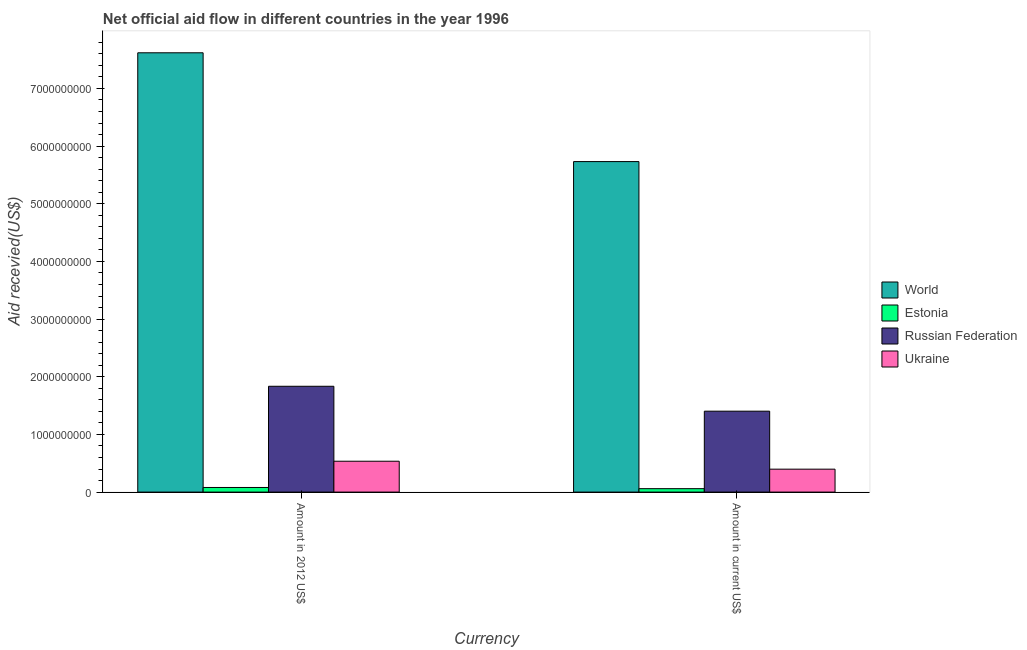How many groups of bars are there?
Provide a succinct answer. 2. Are the number of bars per tick equal to the number of legend labels?
Provide a short and direct response. Yes. Are the number of bars on each tick of the X-axis equal?
Offer a terse response. Yes. What is the label of the 1st group of bars from the left?
Your response must be concise. Amount in 2012 US$. What is the amount of aid received(expressed in 2012 us$) in Russian Federation?
Give a very brief answer. 1.84e+09. Across all countries, what is the maximum amount of aid received(expressed in us$)?
Your answer should be very brief. 5.73e+09. Across all countries, what is the minimum amount of aid received(expressed in 2012 us$)?
Ensure brevity in your answer.  7.99e+07. In which country was the amount of aid received(expressed in 2012 us$) minimum?
Give a very brief answer. Estonia. What is the total amount of aid received(expressed in us$) in the graph?
Provide a short and direct response. 7.59e+09. What is the difference between the amount of aid received(expressed in us$) in Estonia and that in Russian Federation?
Offer a terse response. -1.34e+09. What is the difference between the amount of aid received(expressed in us$) in Ukraine and the amount of aid received(expressed in 2012 us$) in Russian Federation?
Keep it short and to the point. -1.44e+09. What is the average amount of aid received(expressed in 2012 us$) per country?
Provide a succinct answer. 2.52e+09. What is the difference between the amount of aid received(expressed in us$) and amount of aid received(expressed in 2012 us$) in Russian Federation?
Give a very brief answer. -4.32e+08. In how many countries, is the amount of aid received(expressed in us$) greater than 1000000000 US$?
Offer a terse response. 2. What is the ratio of the amount of aid received(expressed in us$) in Ukraine to that in Russian Federation?
Provide a short and direct response. 0.28. Is the amount of aid received(expressed in us$) in Estonia less than that in Russian Federation?
Give a very brief answer. Yes. What does the 3rd bar from the left in Amount in current US$ represents?
Provide a succinct answer. Russian Federation. What does the 2nd bar from the right in Amount in 2012 US$ represents?
Provide a short and direct response. Russian Federation. How many countries are there in the graph?
Offer a terse response. 4. What is the difference between two consecutive major ticks on the Y-axis?
Offer a terse response. 1.00e+09. Does the graph contain grids?
Your answer should be very brief. No. Where does the legend appear in the graph?
Offer a terse response. Center right. How many legend labels are there?
Ensure brevity in your answer.  4. What is the title of the graph?
Keep it short and to the point. Net official aid flow in different countries in the year 1996. What is the label or title of the X-axis?
Offer a terse response. Currency. What is the label or title of the Y-axis?
Provide a succinct answer. Aid recevied(US$). What is the Aid recevied(US$) in World in Amount in 2012 US$?
Offer a very short reply. 7.62e+09. What is the Aid recevied(US$) of Estonia in Amount in 2012 US$?
Offer a very short reply. 7.99e+07. What is the Aid recevied(US$) of Russian Federation in Amount in 2012 US$?
Ensure brevity in your answer.  1.84e+09. What is the Aid recevied(US$) in Ukraine in Amount in 2012 US$?
Give a very brief answer. 5.35e+08. What is the Aid recevied(US$) in World in Amount in current US$?
Offer a very short reply. 5.73e+09. What is the Aid recevied(US$) of Estonia in Amount in current US$?
Give a very brief answer. 5.94e+07. What is the Aid recevied(US$) in Russian Federation in Amount in current US$?
Offer a terse response. 1.40e+09. What is the Aid recevied(US$) in Ukraine in Amount in current US$?
Your answer should be compact. 3.98e+08. Across all Currency, what is the maximum Aid recevied(US$) in World?
Make the answer very short. 7.62e+09. Across all Currency, what is the maximum Aid recevied(US$) of Estonia?
Your answer should be very brief. 7.99e+07. Across all Currency, what is the maximum Aid recevied(US$) of Russian Federation?
Ensure brevity in your answer.  1.84e+09. Across all Currency, what is the maximum Aid recevied(US$) in Ukraine?
Offer a terse response. 5.35e+08. Across all Currency, what is the minimum Aid recevied(US$) in World?
Ensure brevity in your answer.  5.73e+09. Across all Currency, what is the minimum Aid recevied(US$) of Estonia?
Offer a very short reply. 5.94e+07. Across all Currency, what is the minimum Aid recevied(US$) in Russian Federation?
Ensure brevity in your answer.  1.40e+09. Across all Currency, what is the minimum Aid recevied(US$) in Ukraine?
Keep it short and to the point. 3.98e+08. What is the total Aid recevied(US$) of World in the graph?
Your response must be concise. 1.34e+1. What is the total Aid recevied(US$) in Estonia in the graph?
Your answer should be very brief. 1.39e+08. What is the total Aid recevied(US$) of Russian Federation in the graph?
Provide a succinct answer. 3.24e+09. What is the total Aid recevied(US$) in Ukraine in the graph?
Your answer should be compact. 9.33e+08. What is the difference between the Aid recevied(US$) of World in Amount in 2012 US$ and that in Amount in current US$?
Give a very brief answer. 1.89e+09. What is the difference between the Aid recevied(US$) of Estonia in Amount in 2012 US$ and that in Amount in current US$?
Make the answer very short. 2.05e+07. What is the difference between the Aid recevied(US$) of Russian Federation in Amount in 2012 US$ and that in Amount in current US$?
Give a very brief answer. 4.32e+08. What is the difference between the Aid recevied(US$) in Ukraine in Amount in 2012 US$ and that in Amount in current US$?
Your response must be concise. 1.37e+08. What is the difference between the Aid recevied(US$) of World in Amount in 2012 US$ and the Aid recevied(US$) of Estonia in Amount in current US$?
Provide a short and direct response. 7.56e+09. What is the difference between the Aid recevied(US$) in World in Amount in 2012 US$ and the Aid recevied(US$) in Russian Federation in Amount in current US$?
Your response must be concise. 6.22e+09. What is the difference between the Aid recevied(US$) of World in Amount in 2012 US$ and the Aid recevied(US$) of Ukraine in Amount in current US$?
Your answer should be compact. 7.22e+09. What is the difference between the Aid recevied(US$) in Estonia in Amount in 2012 US$ and the Aid recevied(US$) in Russian Federation in Amount in current US$?
Provide a succinct answer. -1.32e+09. What is the difference between the Aid recevied(US$) in Estonia in Amount in 2012 US$ and the Aid recevied(US$) in Ukraine in Amount in current US$?
Your answer should be compact. -3.18e+08. What is the difference between the Aid recevied(US$) of Russian Federation in Amount in 2012 US$ and the Aid recevied(US$) of Ukraine in Amount in current US$?
Give a very brief answer. 1.44e+09. What is the average Aid recevied(US$) of World per Currency?
Give a very brief answer. 6.68e+09. What is the average Aid recevied(US$) of Estonia per Currency?
Offer a terse response. 6.96e+07. What is the average Aid recevied(US$) in Russian Federation per Currency?
Your answer should be very brief. 1.62e+09. What is the average Aid recevied(US$) of Ukraine per Currency?
Your answer should be compact. 4.66e+08. What is the difference between the Aid recevied(US$) in World and Aid recevied(US$) in Estonia in Amount in 2012 US$?
Your answer should be compact. 7.54e+09. What is the difference between the Aid recevied(US$) in World and Aid recevied(US$) in Russian Federation in Amount in 2012 US$?
Your answer should be compact. 5.78e+09. What is the difference between the Aid recevied(US$) of World and Aid recevied(US$) of Ukraine in Amount in 2012 US$?
Your answer should be very brief. 7.08e+09. What is the difference between the Aid recevied(US$) of Estonia and Aid recevied(US$) of Russian Federation in Amount in 2012 US$?
Your answer should be compact. -1.76e+09. What is the difference between the Aid recevied(US$) in Estonia and Aid recevied(US$) in Ukraine in Amount in 2012 US$?
Your answer should be compact. -4.55e+08. What is the difference between the Aid recevied(US$) in Russian Federation and Aid recevied(US$) in Ukraine in Amount in 2012 US$?
Provide a short and direct response. 1.30e+09. What is the difference between the Aid recevied(US$) in World and Aid recevied(US$) in Estonia in Amount in current US$?
Keep it short and to the point. 5.67e+09. What is the difference between the Aid recevied(US$) of World and Aid recevied(US$) of Russian Federation in Amount in current US$?
Offer a terse response. 4.33e+09. What is the difference between the Aid recevied(US$) in World and Aid recevied(US$) in Ukraine in Amount in current US$?
Give a very brief answer. 5.33e+09. What is the difference between the Aid recevied(US$) in Estonia and Aid recevied(US$) in Russian Federation in Amount in current US$?
Make the answer very short. -1.34e+09. What is the difference between the Aid recevied(US$) of Estonia and Aid recevied(US$) of Ukraine in Amount in current US$?
Offer a terse response. -3.38e+08. What is the difference between the Aid recevied(US$) in Russian Federation and Aid recevied(US$) in Ukraine in Amount in current US$?
Give a very brief answer. 1.01e+09. What is the ratio of the Aid recevied(US$) of World in Amount in 2012 US$ to that in Amount in current US$?
Your answer should be compact. 1.33. What is the ratio of the Aid recevied(US$) of Estonia in Amount in 2012 US$ to that in Amount in current US$?
Ensure brevity in your answer.  1.35. What is the ratio of the Aid recevied(US$) of Russian Federation in Amount in 2012 US$ to that in Amount in current US$?
Keep it short and to the point. 1.31. What is the ratio of the Aid recevied(US$) of Ukraine in Amount in 2012 US$ to that in Amount in current US$?
Keep it short and to the point. 1.35. What is the difference between the highest and the second highest Aid recevied(US$) in World?
Give a very brief answer. 1.89e+09. What is the difference between the highest and the second highest Aid recevied(US$) in Estonia?
Your answer should be very brief. 2.05e+07. What is the difference between the highest and the second highest Aid recevied(US$) of Russian Federation?
Give a very brief answer. 4.32e+08. What is the difference between the highest and the second highest Aid recevied(US$) of Ukraine?
Make the answer very short. 1.37e+08. What is the difference between the highest and the lowest Aid recevied(US$) in World?
Offer a very short reply. 1.89e+09. What is the difference between the highest and the lowest Aid recevied(US$) in Estonia?
Your answer should be compact. 2.05e+07. What is the difference between the highest and the lowest Aid recevied(US$) of Russian Federation?
Provide a short and direct response. 4.32e+08. What is the difference between the highest and the lowest Aid recevied(US$) of Ukraine?
Provide a short and direct response. 1.37e+08. 